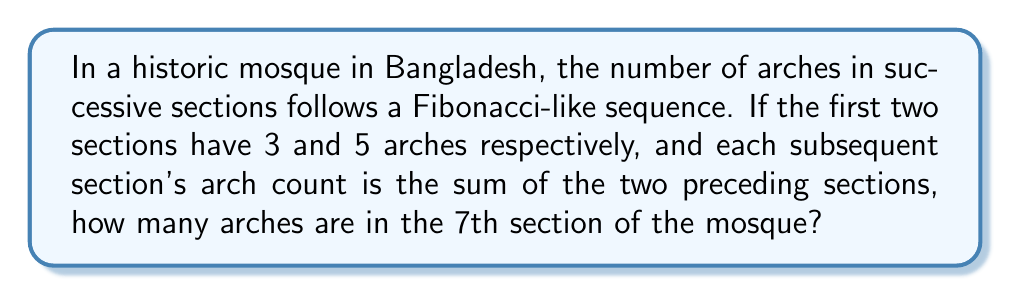Teach me how to tackle this problem. Let's solve this step-by-step:

1) First, let's write out the sequence for the first few terms:
   Section 1: 3 arches
   Section 2: 5 arches
   
2) For each subsequent section, we add the two previous terms:
   Section 3: 3 + 5 = 8 arches
   Section 4: 5 + 8 = 13 arches
   Section 5: 8 + 13 = 21 arches
   Section 6: 13 + 21 = 34 arches
   
3) For the 7th section, we add the 5th and 6th terms:
   Section 7: 21 + 34 = 55 arches

4) We can represent this sequence mathematically as:

   $$a_n = a_{n-1} + a_{n-2}$$

   Where $a_n$ is the number of arches in the nth section, with initial conditions:
   $a_1 = 3$ and $a_2 = 5$

5) This is indeed a Fibonacci-like sequence, differing from the classic Fibonacci sequence only in its starting values.
Answer: 55 arches 